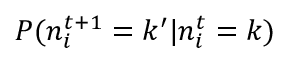Convert formula to latex. <formula><loc_0><loc_0><loc_500><loc_500>P ( n _ { i } ^ { t + 1 } = k ^ { \prime } | n _ { i } ^ { t } = k )</formula> 